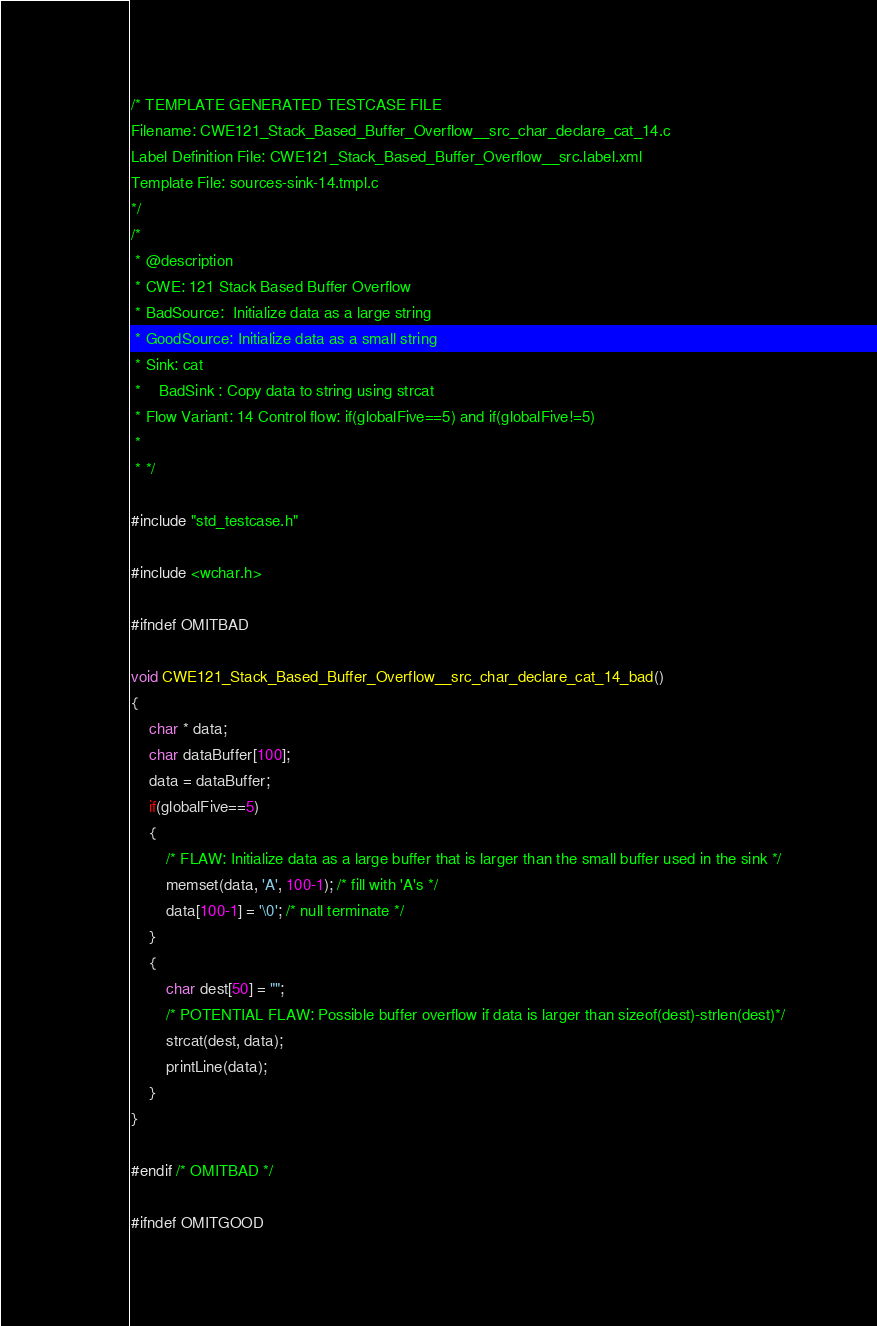<code> <loc_0><loc_0><loc_500><loc_500><_C_>/* TEMPLATE GENERATED TESTCASE FILE
Filename: CWE121_Stack_Based_Buffer_Overflow__src_char_declare_cat_14.c
Label Definition File: CWE121_Stack_Based_Buffer_Overflow__src.label.xml
Template File: sources-sink-14.tmpl.c
*/
/*
 * @description
 * CWE: 121 Stack Based Buffer Overflow
 * BadSource:  Initialize data as a large string
 * GoodSource: Initialize data as a small string
 * Sink: cat
 *    BadSink : Copy data to string using strcat
 * Flow Variant: 14 Control flow: if(globalFive==5) and if(globalFive!=5)
 *
 * */

#include "std_testcase.h"

#include <wchar.h>

#ifndef OMITBAD

void CWE121_Stack_Based_Buffer_Overflow__src_char_declare_cat_14_bad()
{
    char * data;
    char dataBuffer[100];
    data = dataBuffer;
    if(globalFive==5)
    {
        /* FLAW: Initialize data as a large buffer that is larger than the small buffer used in the sink */
        memset(data, 'A', 100-1); /* fill with 'A's */
        data[100-1] = '\0'; /* null terminate */
    }
    {
        char dest[50] = "";
        /* POTENTIAL FLAW: Possible buffer overflow if data is larger than sizeof(dest)-strlen(dest)*/
        strcat(dest, data);
        printLine(data);
    }
}

#endif /* OMITBAD */

#ifndef OMITGOOD
</code> 